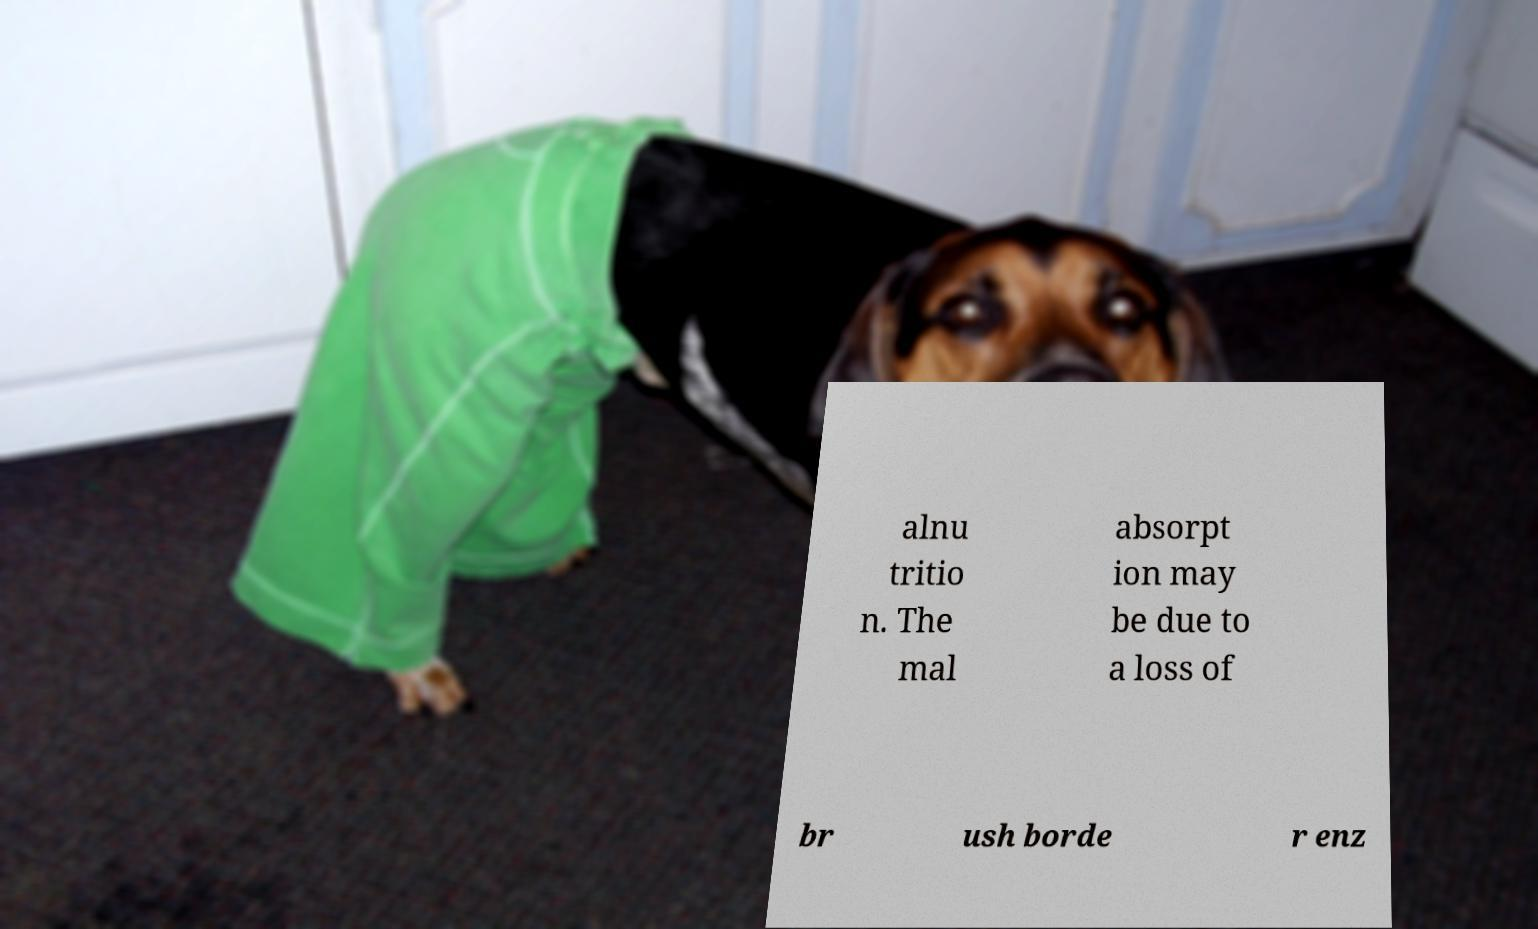Can you read and provide the text displayed in the image?This photo seems to have some interesting text. Can you extract and type it out for me? alnu tritio n. The mal absorpt ion may be due to a loss of br ush borde r enz 